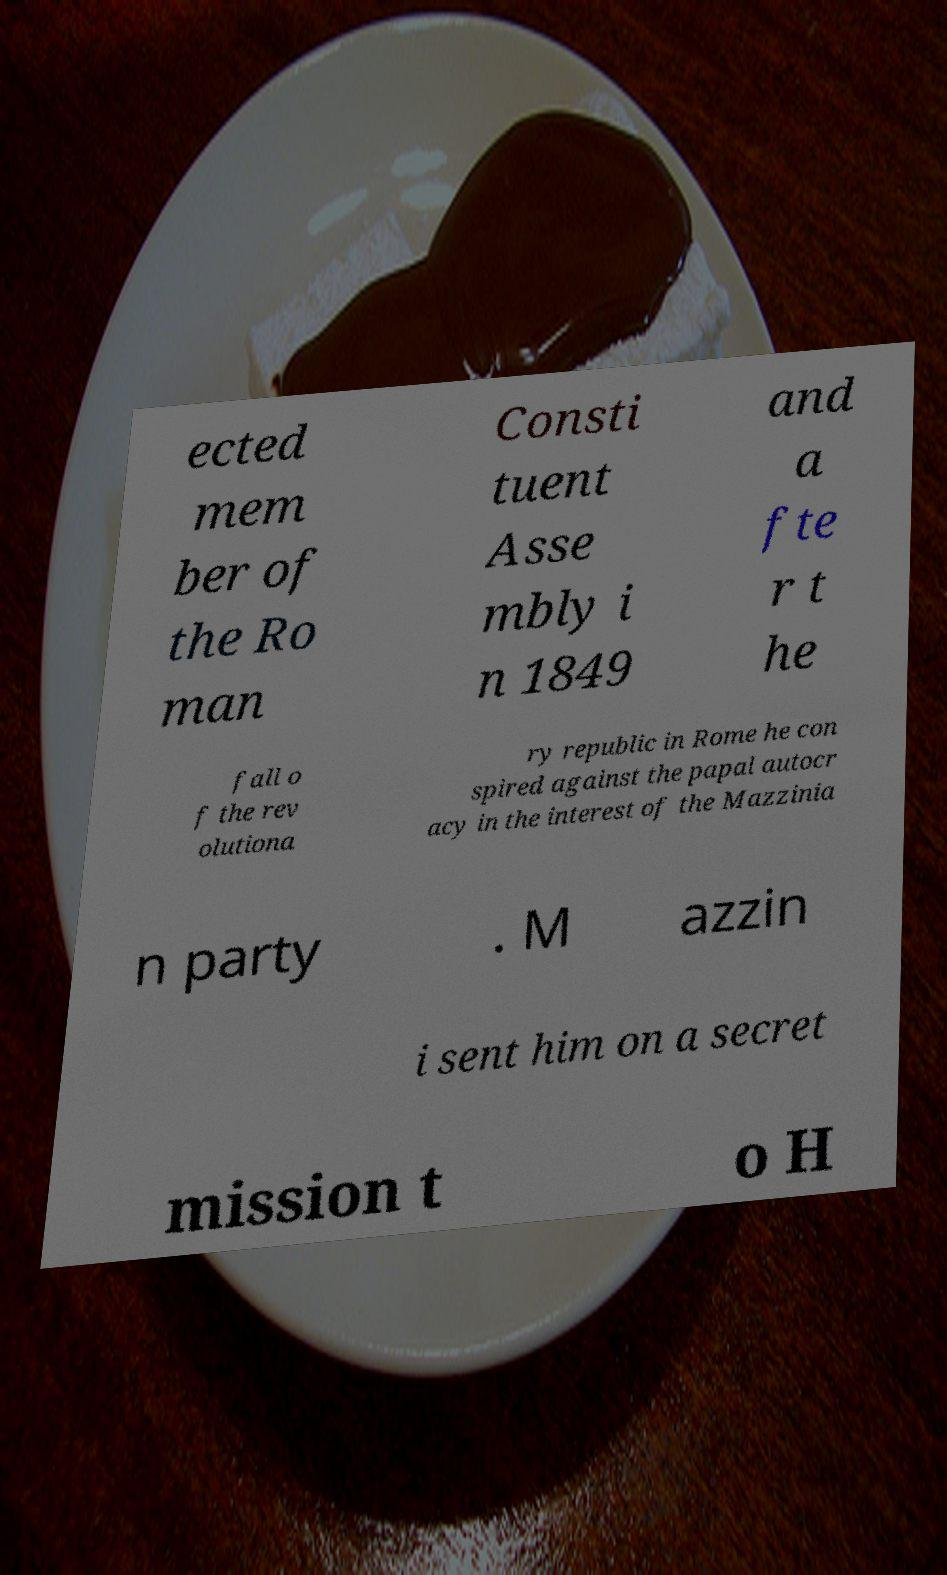Can you accurately transcribe the text from the provided image for me? ected mem ber of the Ro man Consti tuent Asse mbly i n 1849 and a fte r t he fall o f the rev olutiona ry republic in Rome he con spired against the papal autocr acy in the interest of the Mazzinia n party . M azzin i sent him on a secret mission t o H 